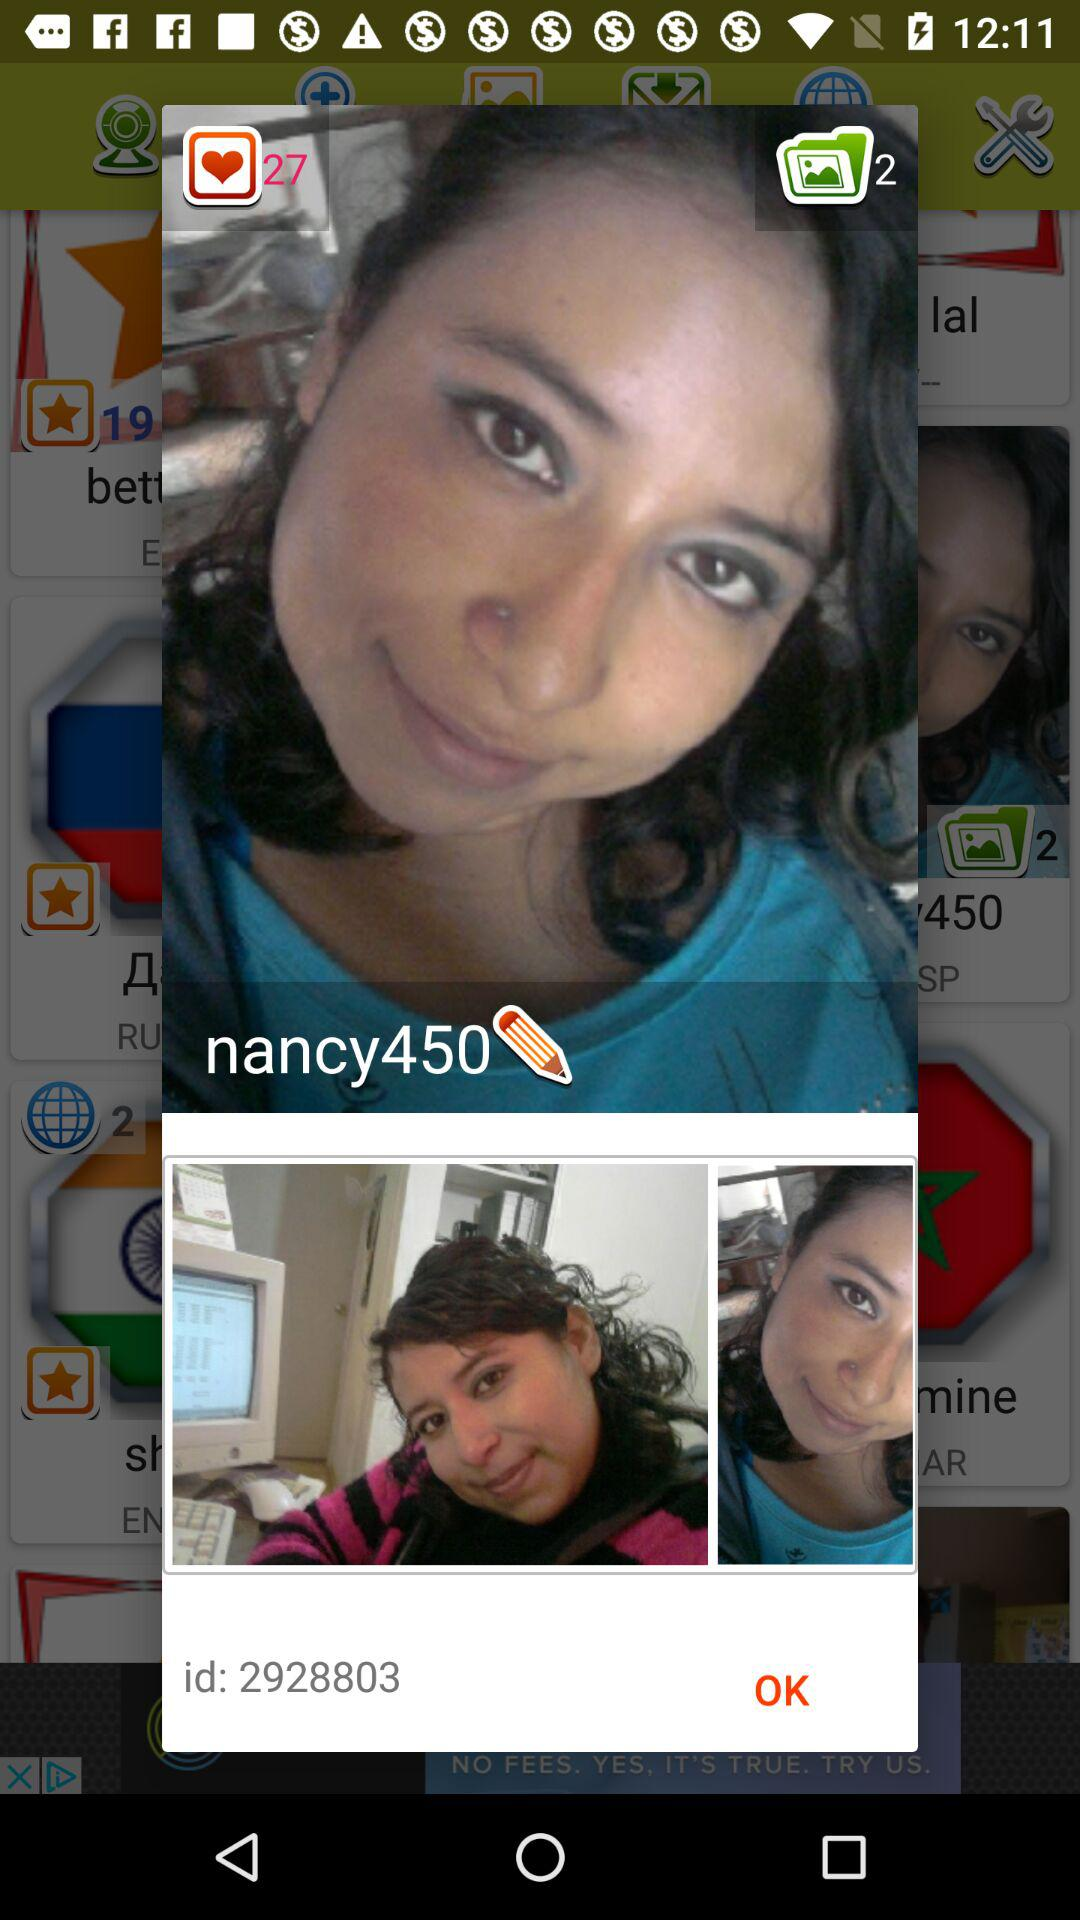What's the total number of photos? The total number of photos is 2. 